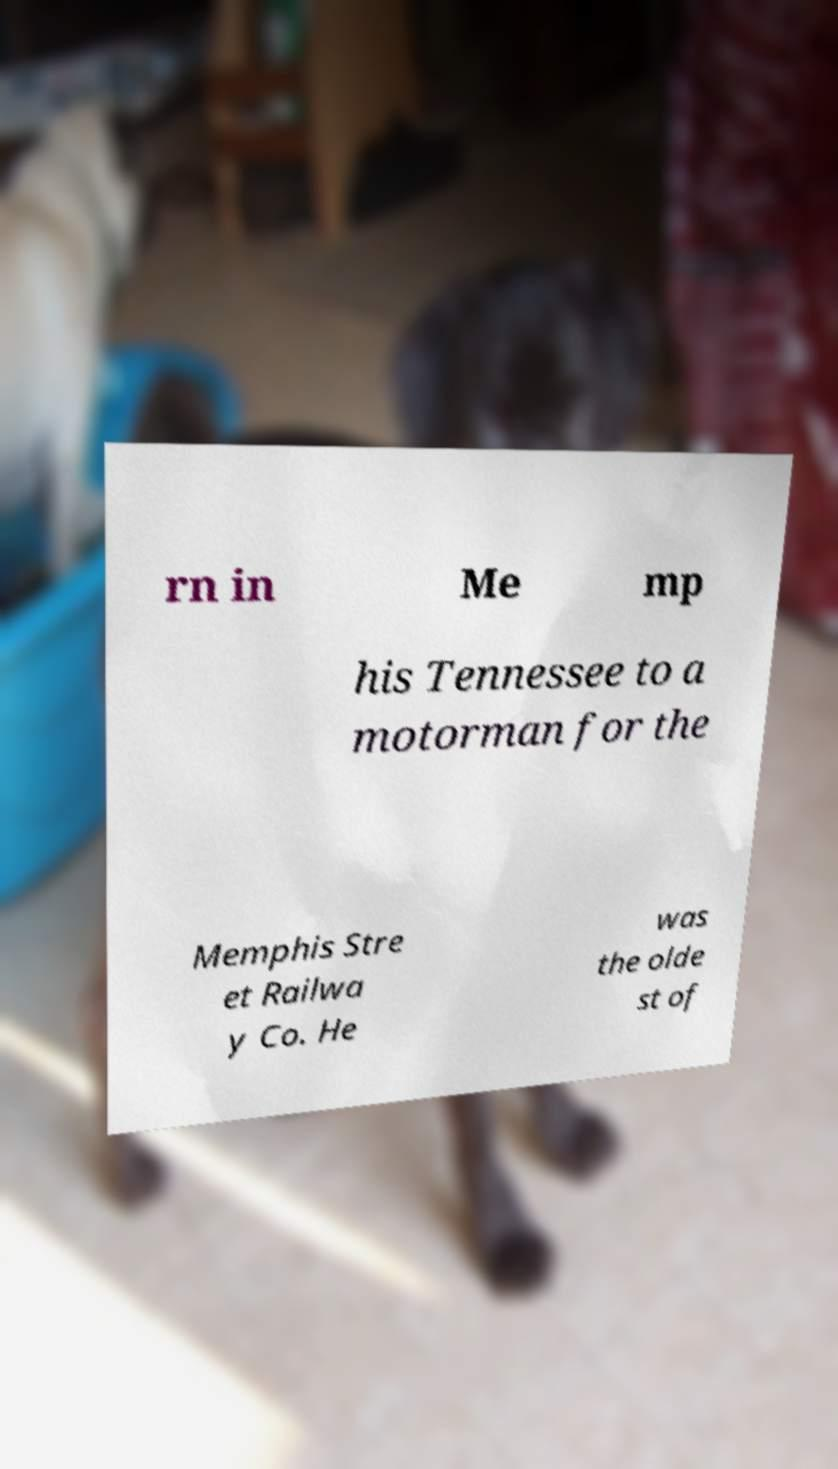I need the written content from this picture converted into text. Can you do that? rn in Me mp his Tennessee to a motorman for the Memphis Stre et Railwa y Co. He was the olde st of 